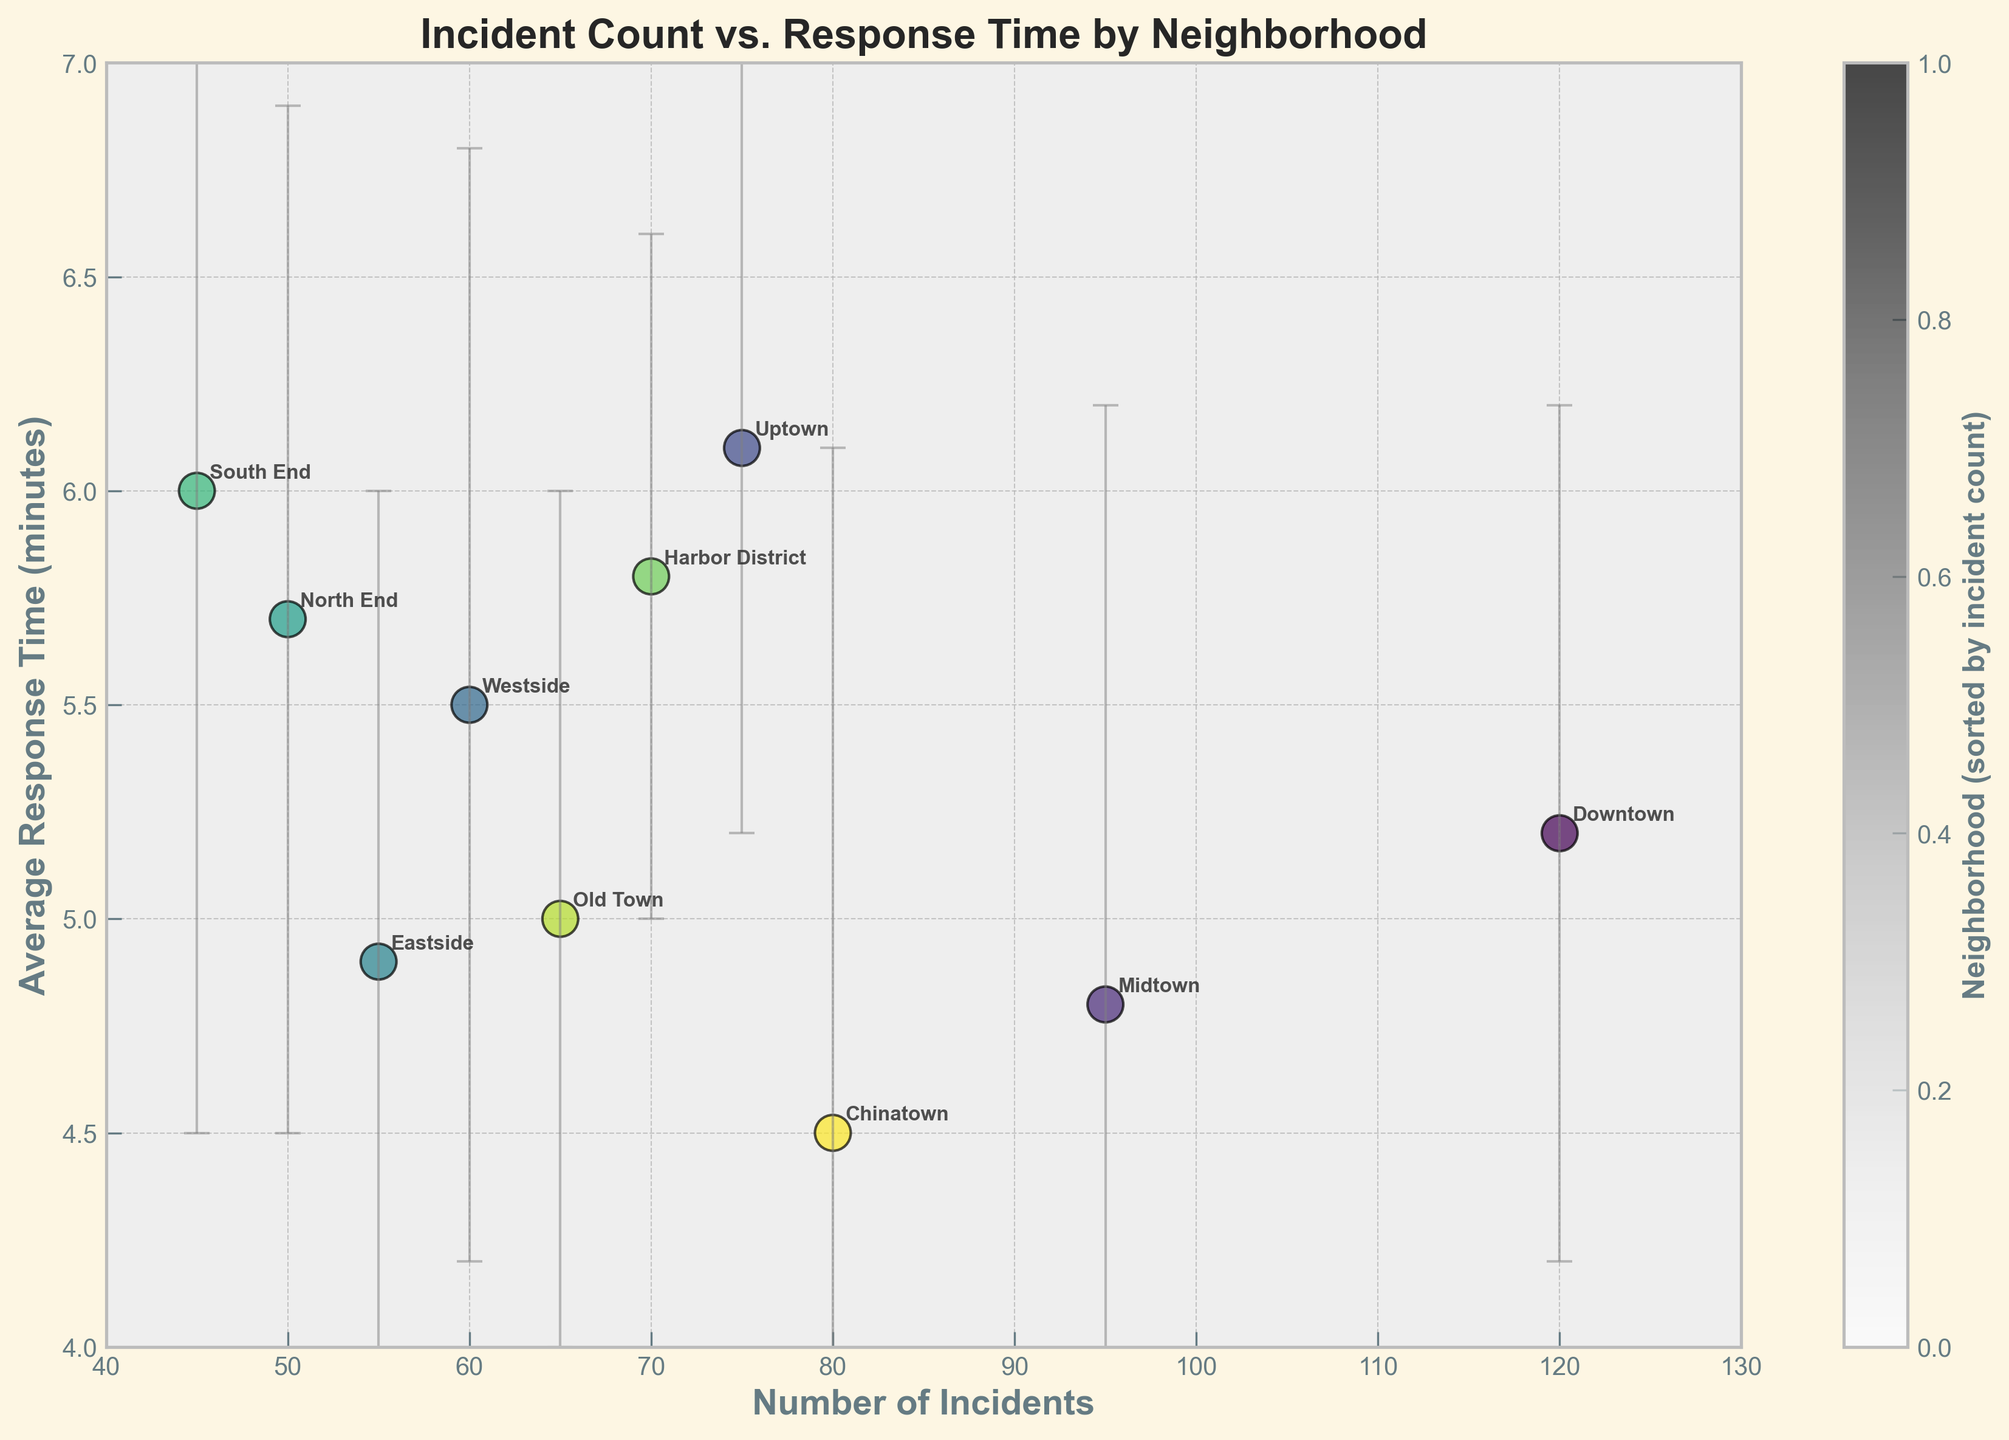What is the title of the chart? The title is usually displayed at the top of the chart. In this case, it reads "Incident Count vs. Response Time by Neighborhood."
Answer: Incident Count vs. Response Time by Neighborhood How many neighborhoods are represented in the chart? To determine the number of neighborhoods, count the number of labeled dots on the scatter plot. Each neighborhood is a unique data point.
Answer: 10 Which neighborhood has the highest number of incidents? On the x-axis labeled "Number of Incidents," locate the rightmost scatter plot point. The label next to it will identify the neighborhood with the highest number of incidents.
Answer: Downtown What is the average response time for Eastside? Locate the point labeled "Eastside," then look at its position on the y-axis marked "Average Response Time (minutes)."
Answer: 4.9 minutes Which neighborhoods have an average response time greater than 5.5 minutes? Identify points above the y-axis value of 5.5 and read the corresponding neighborhood labels.
Answer: Uptown, North End, South End, Harbor District Which neighborhood has the smallest standard deviation in response time? The smallest error bar (vertical line through the point) indicates the smallest standard deviation. Find the shortest error bar and read its label.
Answer: Harbor District What is the difference in the number of incidents between Old Town and Chinatown? Find the "Number of Incidents" values for Old Town and Chinatown, then subtract the smaller value from the larger one. Chinatown has 80 incidents, and Old Town has 65. Calculation: 80 - 65 = 15.
Answer: 15 Which two neighborhoods have the closest average response times? Look for two points whose positions on the y-axis (average response times) are nearest each other, then read their labels.
Answer: Downtown and Eastside Is there any neighborhood with an average response time equal to the overall average of all response times? Calculate the overall average of "Response_Time_Avg" values and see if any neighborhood's point lies exactly on this value. Calculation: (5.2 + 4.8 + 6.1 + 5.5 + 4.9 + 5.7 + 6.0 + 5.8 + 5.0 + 4.5) / 10 = 5.35. No neighborhood has exactly 5.35.
Answer: No What is the relationship between the number of incidents and response time based on the plotted data? Observe the general pattern of the scatter plot points. If more incidents generally coincide with higher or lower response times, there is a clear relationship. However, if points are scattered without a clear trend, no strong relationship exists.
Answer: No strong relationship 